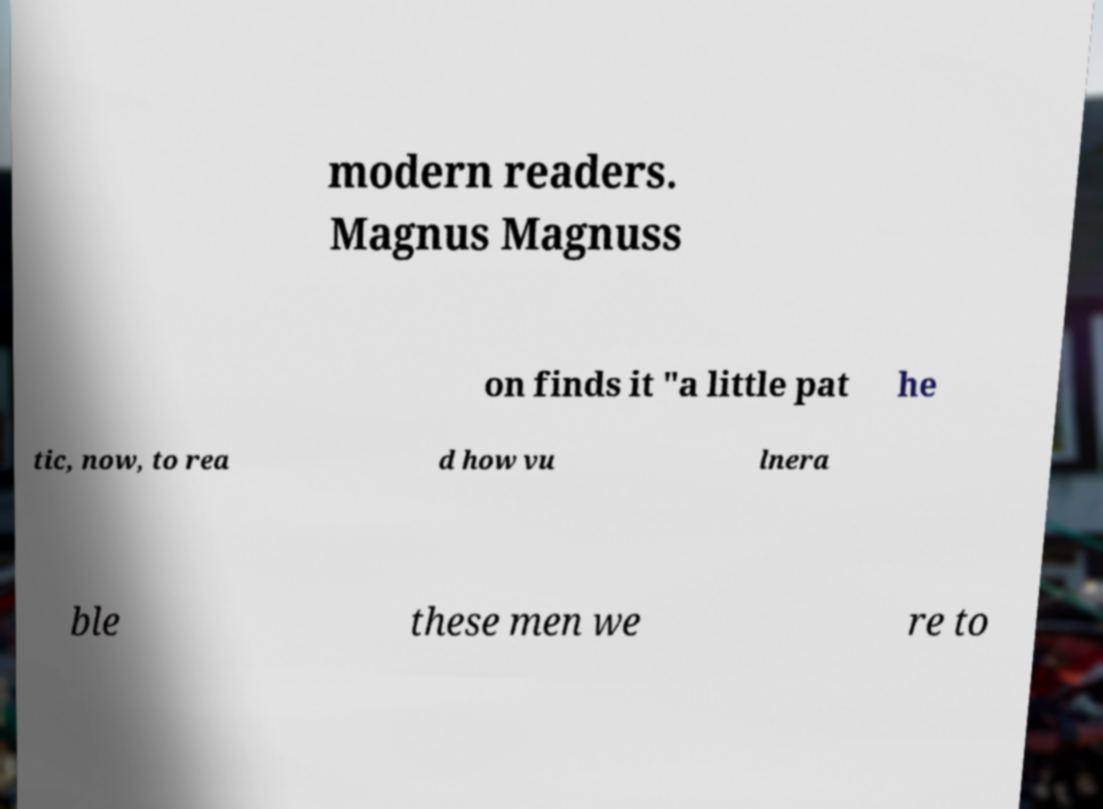What messages or text are displayed in this image? I need them in a readable, typed format. modern readers. Magnus Magnuss on finds it "a little pat he tic, now, to rea d how vu lnera ble these men we re to 